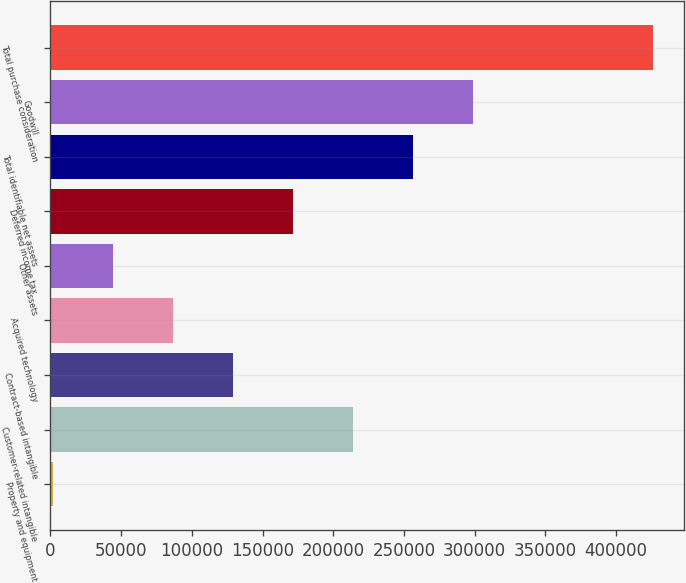Convert chart to OTSL. <chart><loc_0><loc_0><loc_500><loc_500><bar_chart><fcel>Property and equipment<fcel>Customer-related intangible<fcel>Contract-based intangible<fcel>Acquired technology<fcel>Other assets<fcel>Deferred income tax<fcel>Total identifiable net assets<fcel>Goodwill<fcel>Total purchase consideration<nl><fcel>1680<fcel>214066<fcel>129112<fcel>86634.4<fcel>44157.2<fcel>171589<fcel>256543<fcel>299020<fcel>426452<nl></chart> 